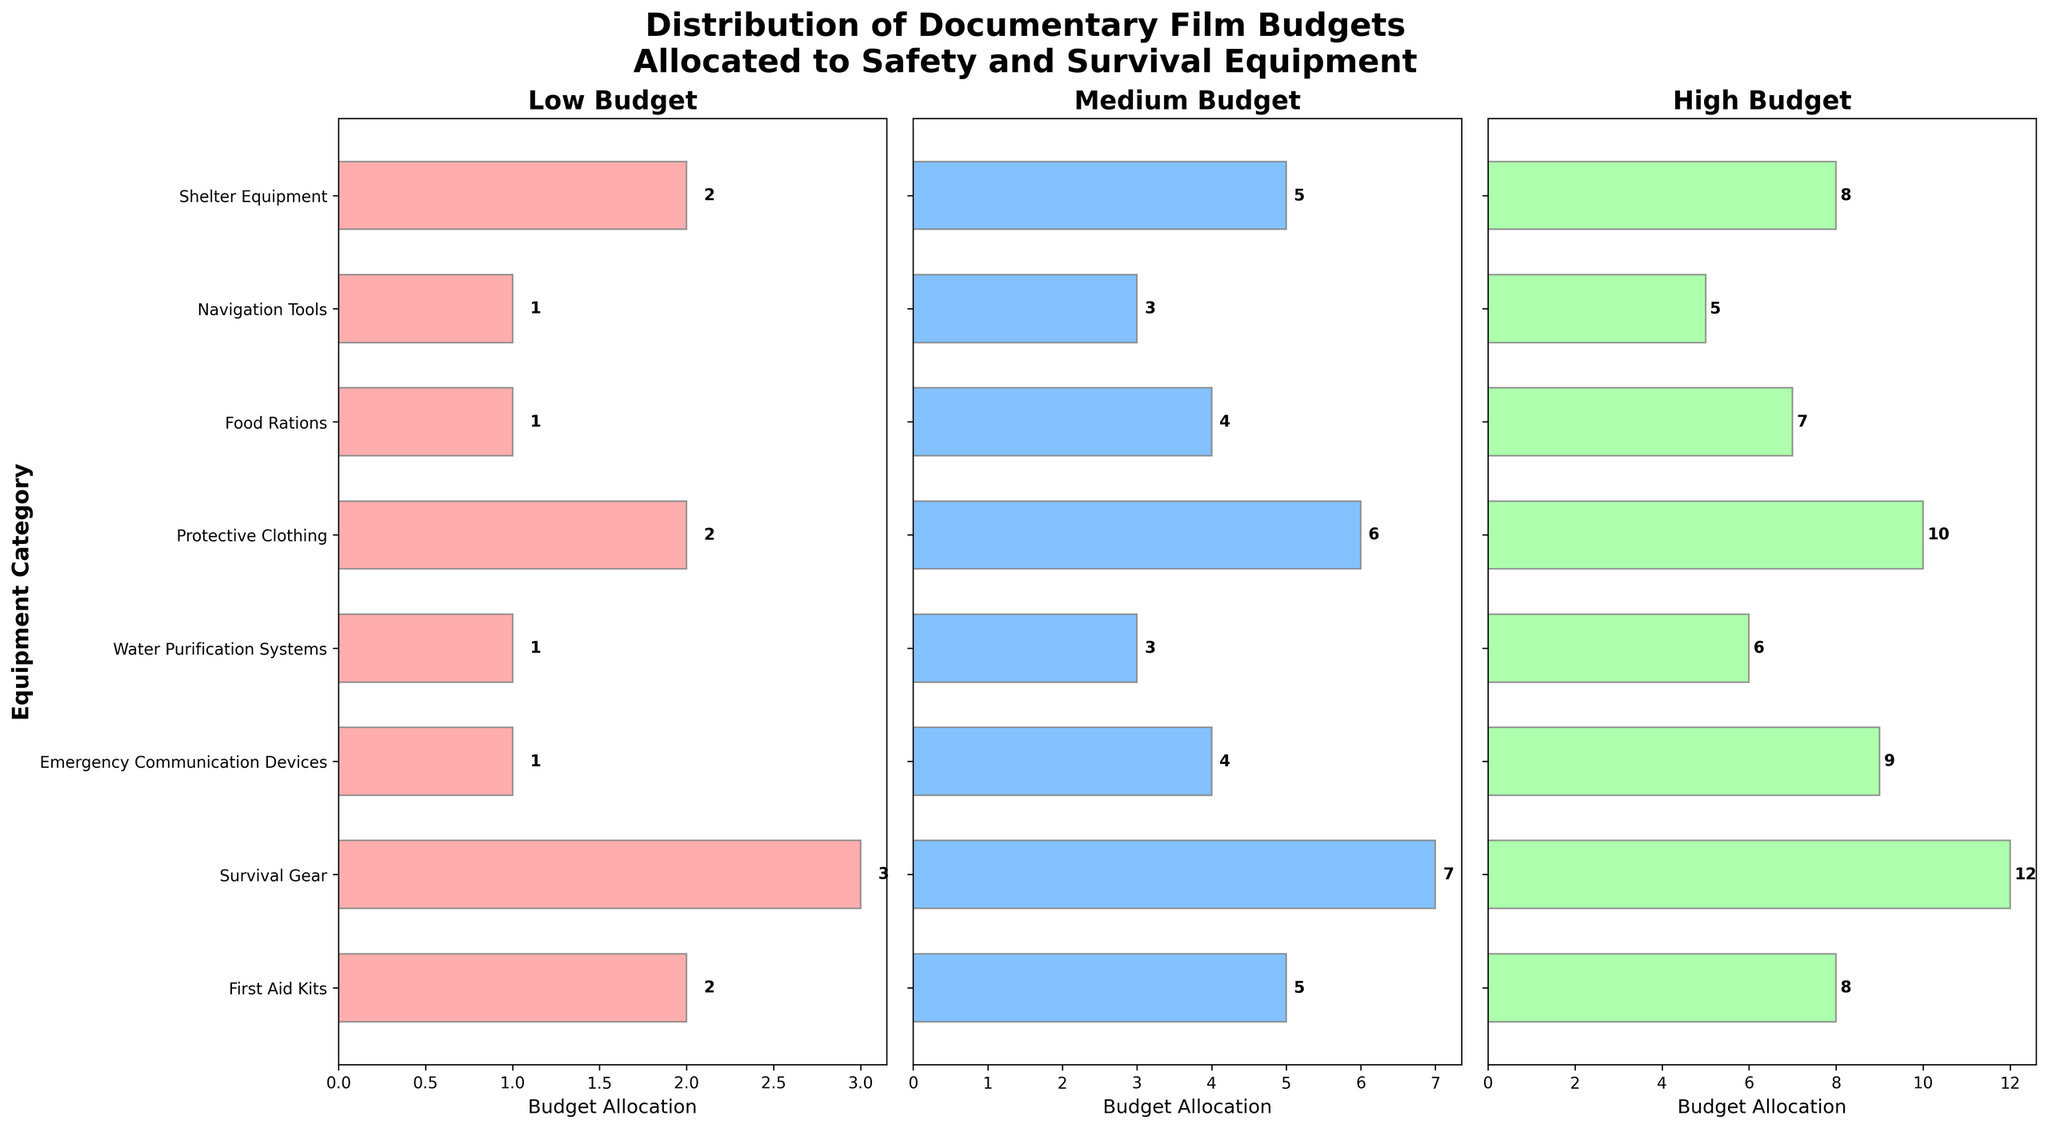what is the title of the figure? The title is displayed at the top of the figure. It reads: "Distribution of Documentary Film Budgets Allocated to Safety and Survival Equipment".
Answer: "Distribution of Documentary Film Budgets Allocated to Safety and Survival Equipment" How much budget is allocated to First Aid Kits in the High Budget category? To find the answer, look at the High Budget subplot and locate the bar corresponding to First Aid Kits. The value at the end of this bar is 8.
Answer: 8 Which category has the highest allocated budget in the Medium Budget category? Examine all the bars in the Medium Budget subplot and identify the one with the maximum value. Survival Gear has the highest budget allocated, with a value of 7.
Answer: Survival Gear What is the combined total budget allocation for Protective Clothing across all budget categories? Add the values for Protective Clothing in Low Budget (2), Medium Budget (6), and High Budget (10): 2 + 6 + 10 = 18.
Answer: 18 In the Low Budget category, which two categories have the same budget allocation? Check the length of the bars in the Low Budget subplot. Both First Aid Kits and Protective Clothing have an allocation of 2.
Answer: First Aid Kits and Protective Clothing What trend can be observed as we move from Low Budget to High Budget in the Emergency Communication Devices category? Look at the length of the bars for Emergency Communication Devices in each subplot. It increases steadily: 1 (Low Budget), 4 (Medium Budget), 9 (High Budget).
Answer: The budget increases steadily Which category has the least allocation in the Low Budget category, and how much is it? In the Low Budget subplot, observe the shortest bar. It corresponds to Emergency Communication Devices and Water Purification Systems, both with a value of 1.
Answer: Emergency Communication Devices and Water Purification Systems, 1 What is the average budget allocation for Food Rations across all budget levels? Calculate the average by adding the values: 1 (Low) + 4 (Medium) + 7 (High) = 12, then divide by 3: 12/3 = 4.
Answer: 4 Compare the budget allocation for Shelter Equipment and Navigation Tools in the Medium Budget category. Which one receives more budget? In the Medium Budget subplot, compare the length of the bars for Shelter Equipment and Navigation Tools. Shelter Equipment has a higher value of 5 compared to Navigation Tools' value of 3.
Answer: Shelter Equipment How much more budget is allocated to Survival Gear compared to Food Rations in the High Budget category? Find the bars for Survival Gear and Food Rations in the High Budget subplot. Survival Gear has a value of 12, and Food Rations have 7. The difference is 12 - 7 = 5.
Answer: 5 